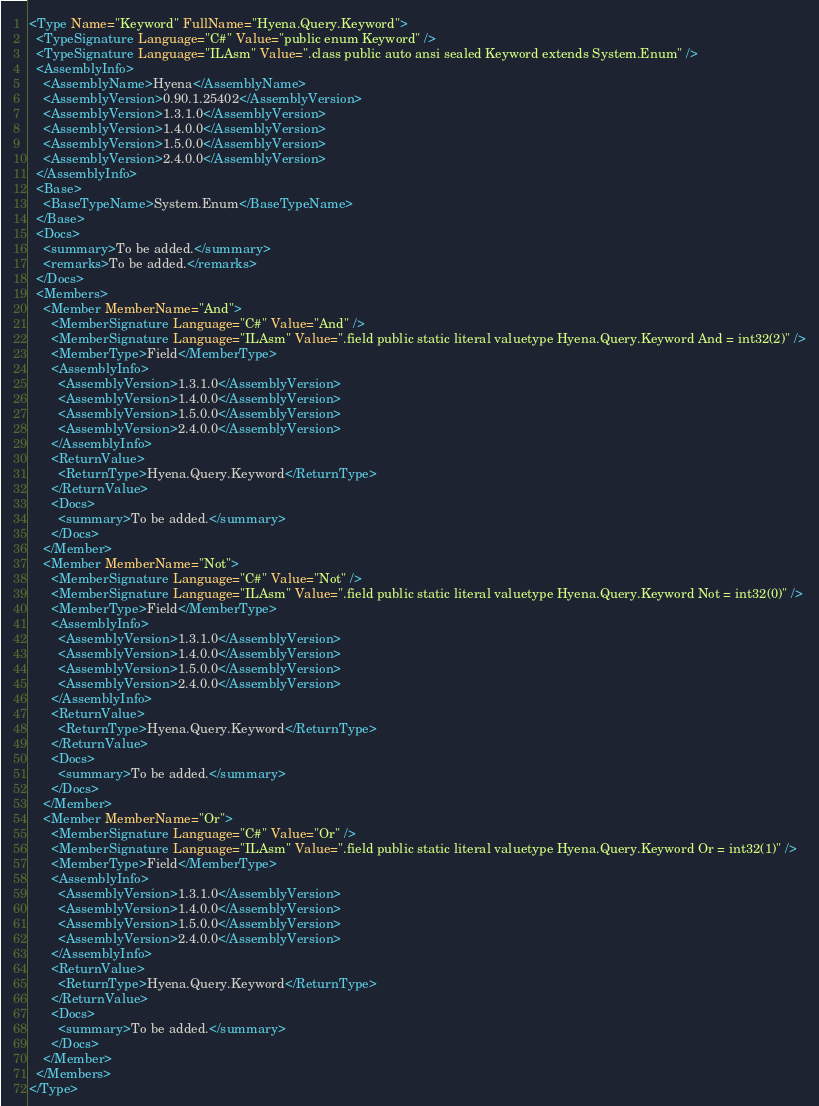<code> <loc_0><loc_0><loc_500><loc_500><_XML_><Type Name="Keyword" FullName="Hyena.Query.Keyword">
  <TypeSignature Language="C#" Value="public enum Keyword" />
  <TypeSignature Language="ILAsm" Value=".class public auto ansi sealed Keyword extends System.Enum" />
  <AssemblyInfo>
    <AssemblyName>Hyena</AssemblyName>
    <AssemblyVersion>0.90.1.25402</AssemblyVersion>
    <AssemblyVersion>1.3.1.0</AssemblyVersion>
    <AssemblyVersion>1.4.0.0</AssemblyVersion>
    <AssemblyVersion>1.5.0.0</AssemblyVersion>
    <AssemblyVersion>2.4.0.0</AssemblyVersion>
  </AssemblyInfo>
  <Base>
    <BaseTypeName>System.Enum</BaseTypeName>
  </Base>
  <Docs>
    <summary>To be added.</summary>
    <remarks>To be added.</remarks>
  </Docs>
  <Members>
    <Member MemberName="And">
      <MemberSignature Language="C#" Value="And" />
      <MemberSignature Language="ILAsm" Value=".field public static literal valuetype Hyena.Query.Keyword And = int32(2)" />
      <MemberType>Field</MemberType>
      <AssemblyInfo>
        <AssemblyVersion>1.3.1.0</AssemblyVersion>
        <AssemblyVersion>1.4.0.0</AssemblyVersion>
        <AssemblyVersion>1.5.0.0</AssemblyVersion>
        <AssemblyVersion>2.4.0.0</AssemblyVersion>
      </AssemblyInfo>
      <ReturnValue>
        <ReturnType>Hyena.Query.Keyword</ReturnType>
      </ReturnValue>
      <Docs>
        <summary>To be added.</summary>
      </Docs>
    </Member>
    <Member MemberName="Not">
      <MemberSignature Language="C#" Value="Not" />
      <MemberSignature Language="ILAsm" Value=".field public static literal valuetype Hyena.Query.Keyword Not = int32(0)" />
      <MemberType>Field</MemberType>
      <AssemblyInfo>
        <AssemblyVersion>1.3.1.0</AssemblyVersion>
        <AssemblyVersion>1.4.0.0</AssemblyVersion>
        <AssemblyVersion>1.5.0.0</AssemblyVersion>
        <AssemblyVersion>2.4.0.0</AssemblyVersion>
      </AssemblyInfo>
      <ReturnValue>
        <ReturnType>Hyena.Query.Keyword</ReturnType>
      </ReturnValue>
      <Docs>
        <summary>To be added.</summary>
      </Docs>
    </Member>
    <Member MemberName="Or">
      <MemberSignature Language="C#" Value="Or" />
      <MemberSignature Language="ILAsm" Value=".field public static literal valuetype Hyena.Query.Keyword Or = int32(1)" />
      <MemberType>Field</MemberType>
      <AssemblyInfo>
        <AssemblyVersion>1.3.1.0</AssemblyVersion>
        <AssemblyVersion>1.4.0.0</AssemblyVersion>
        <AssemblyVersion>1.5.0.0</AssemblyVersion>
        <AssemblyVersion>2.4.0.0</AssemblyVersion>
      </AssemblyInfo>
      <ReturnValue>
        <ReturnType>Hyena.Query.Keyword</ReturnType>
      </ReturnValue>
      <Docs>
        <summary>To be added.</summary>
      </Docs>
    </Member>
  </Members>
</Type>
</code> 